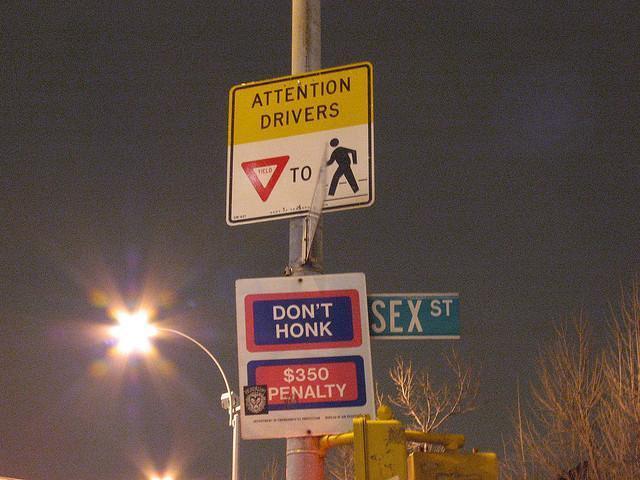How many signs are there?
Give a very brief answer. 3. 